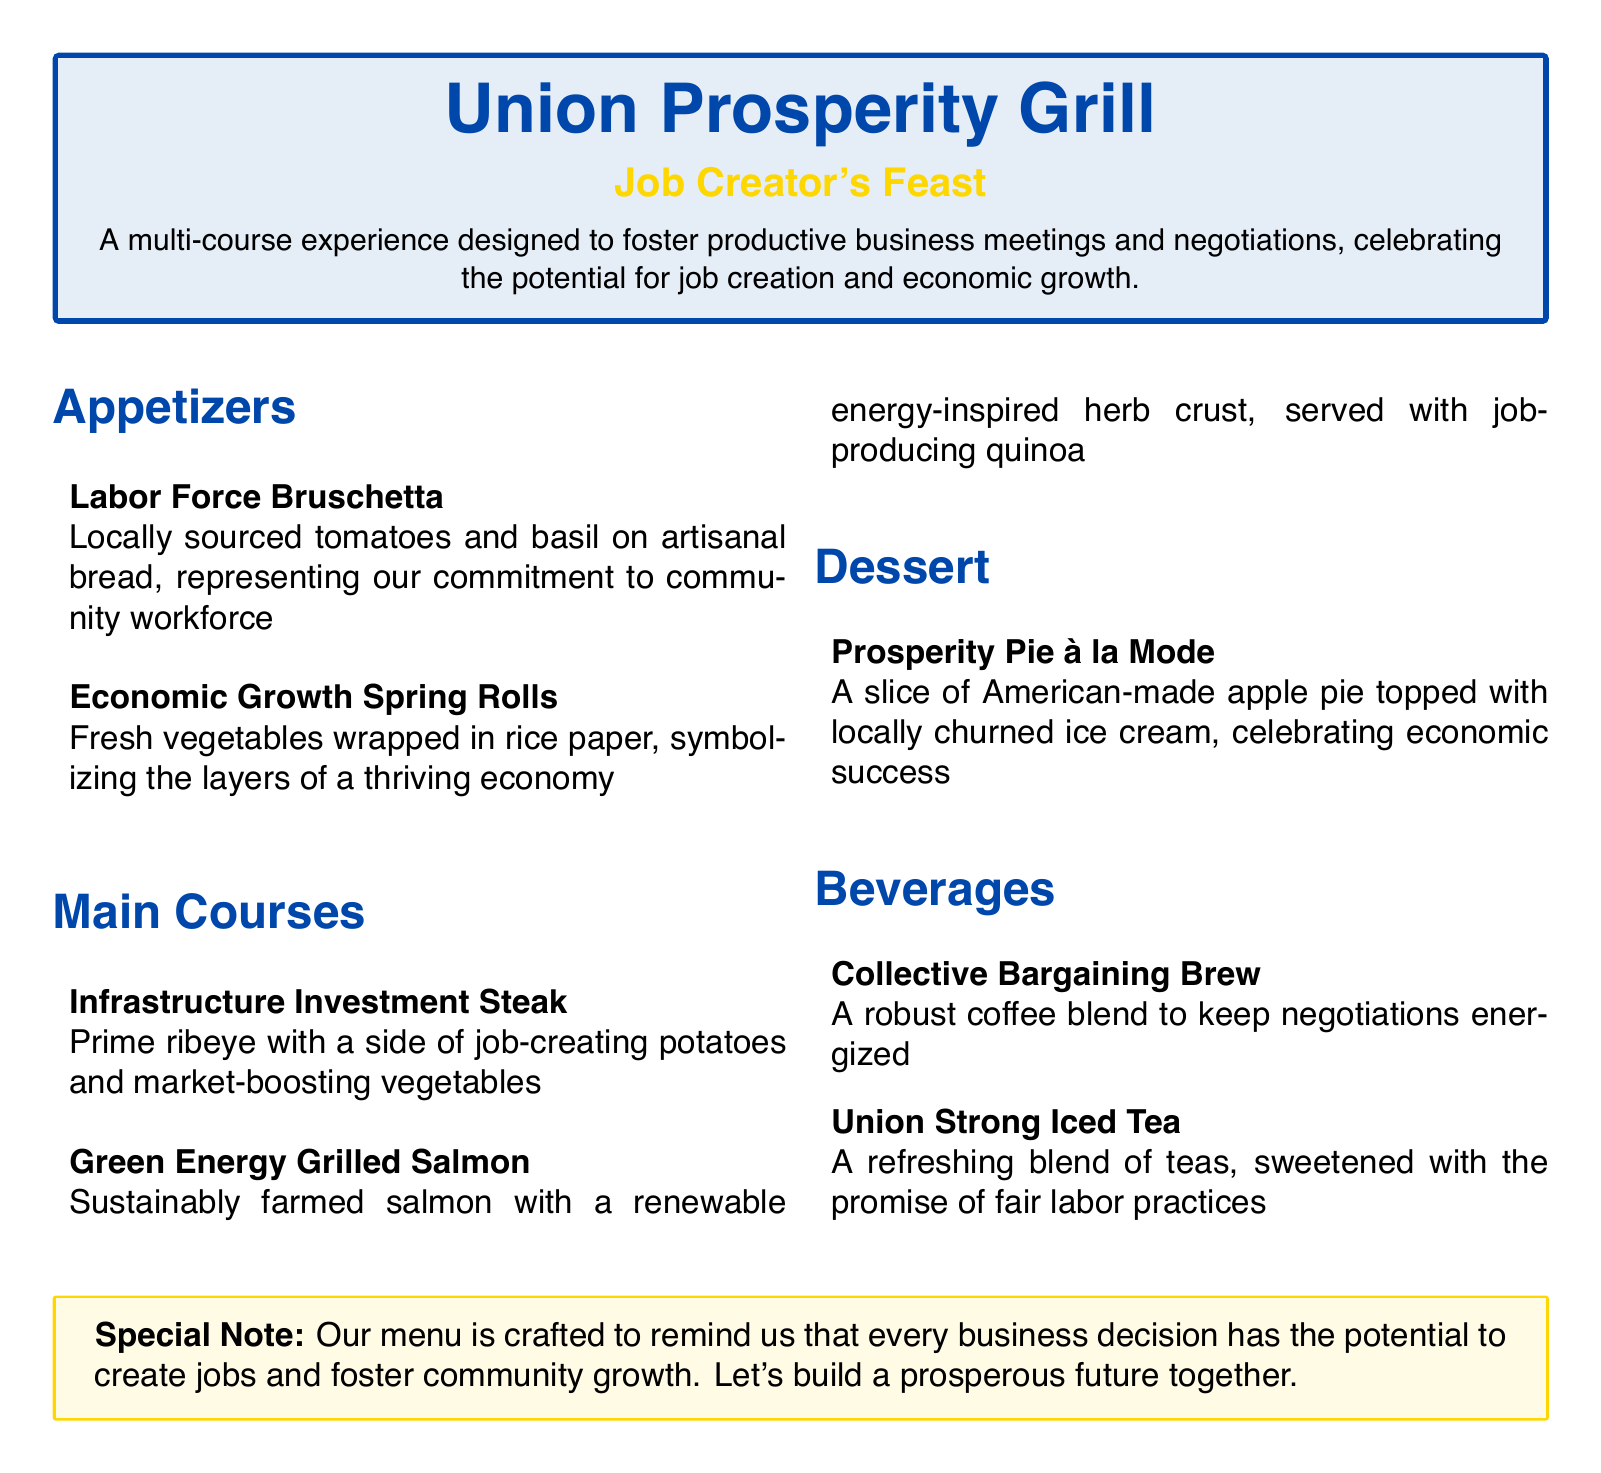what is the name of the restaurant? The name of the restaurant is prominently displayed at the top of the document.
Answer: Union Prosperity Grill what is the title of the menu? The title of the menu is highlighted to show the special theme of the dining experience.
Answer: Job Creator's Feast how many appetizers are listed on the menu? The appetizers section provides two examples of offerings, indicating the total.
Answer: 2 what does the Infrastructure Investment Steak come with? The description of the steak outlines its accompanying sides, integral to the dish.
Answer: job-creating potatoes and market-boosting vegetables what beverage is meant to keep negotiations energized? The menu specifies a robust coffee drink aimed at enhancing focus during discussions.
Answer: Collective Bargaining Brew which dessert represents economic success? The dessert section describes a pie that symbolizes the theme of prosperity and success.
Answer: Prosperity Pie à la Mode what is a symbol represented by the Economic Growth Spring Rolls? The menu explains the significance behind each dish, illustrating its deeper meaning.
Answer: layers of a thriving economy what herb crust is mentioned for the Green Energy Grilled Salmon? The dish's description includes a reference to the inspiration for its flavor profile.
Answer: renewable energy-inspired what is the special note about the menu? The document features a box that conveys a key message regarding the dining experience's intent.
Answer: Every business decision has the potential to create jobs and foster community growth 